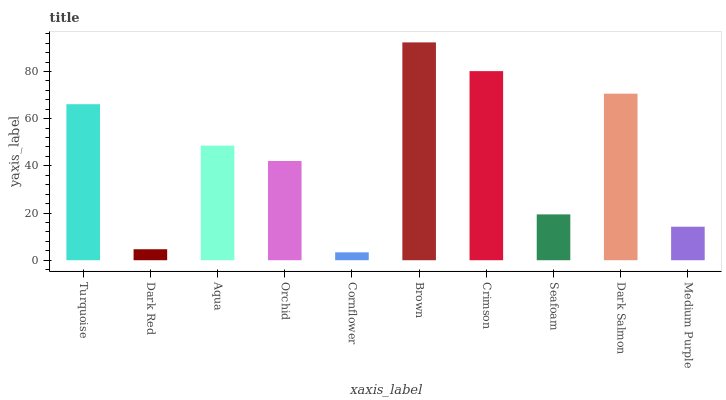Is Brown the maximum?
Answer yes or no. Yes. Is Dark Red the minimum?
Answer yes or no. No. Is Dark Red the maximum?
Answer yes or no. No. Is Turquoise greater than Dark Red?
Answer yes or no. Yes. Is Dark Red less than Turquoise?
Answer yes or no. Yes. Is Dark Red greater than Turquoise?
Answer yes or no. No. Is Turquoise less than Dark Red?
Answer yes or no. No. Is Aqua the high median?
Answer yes or no. Yes. Is Orchid the low median?
Answer yes or no. Yes. Is Cornflower the high median?
Answer yes or no. No. Is Turquoise the low median?
Answer yes or no. No. 